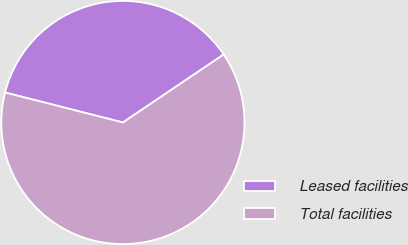Convert chart. <chart><loc_0><loc_0><loc_500><loc_500><pie_chart><fcel>Leased facilities<fcel>Total facilities<nl><fcel>36.59%<fcel>63.41%<nl></chart> 